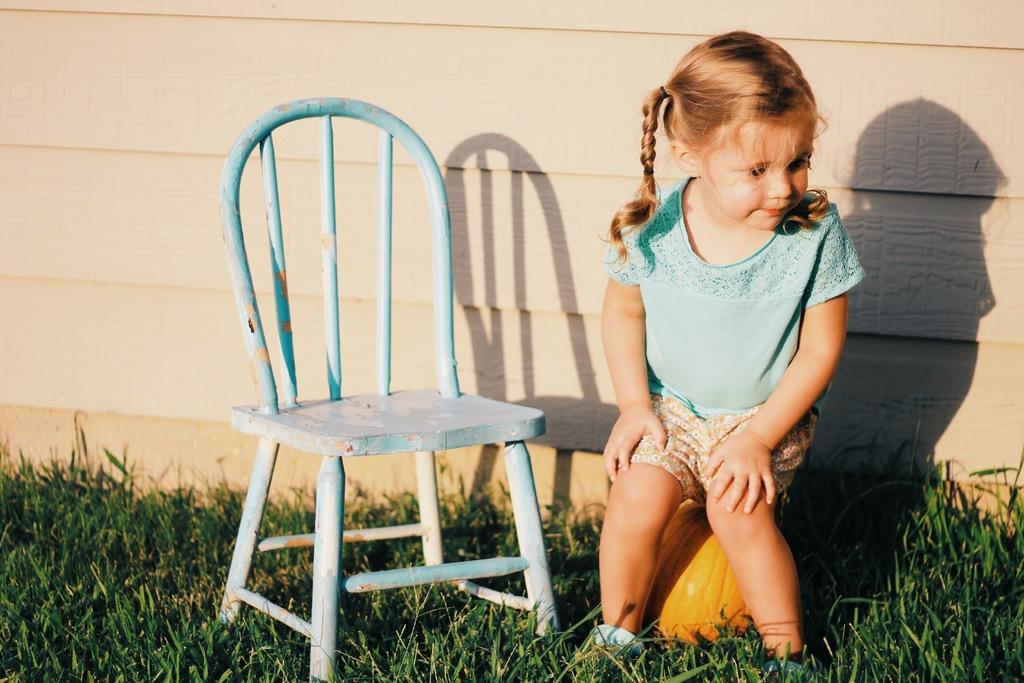Please provide a concise description of this image. In this image there is a girl sitting on the pumpkin and there is a chair on the grass, and in the background there is a wall. 